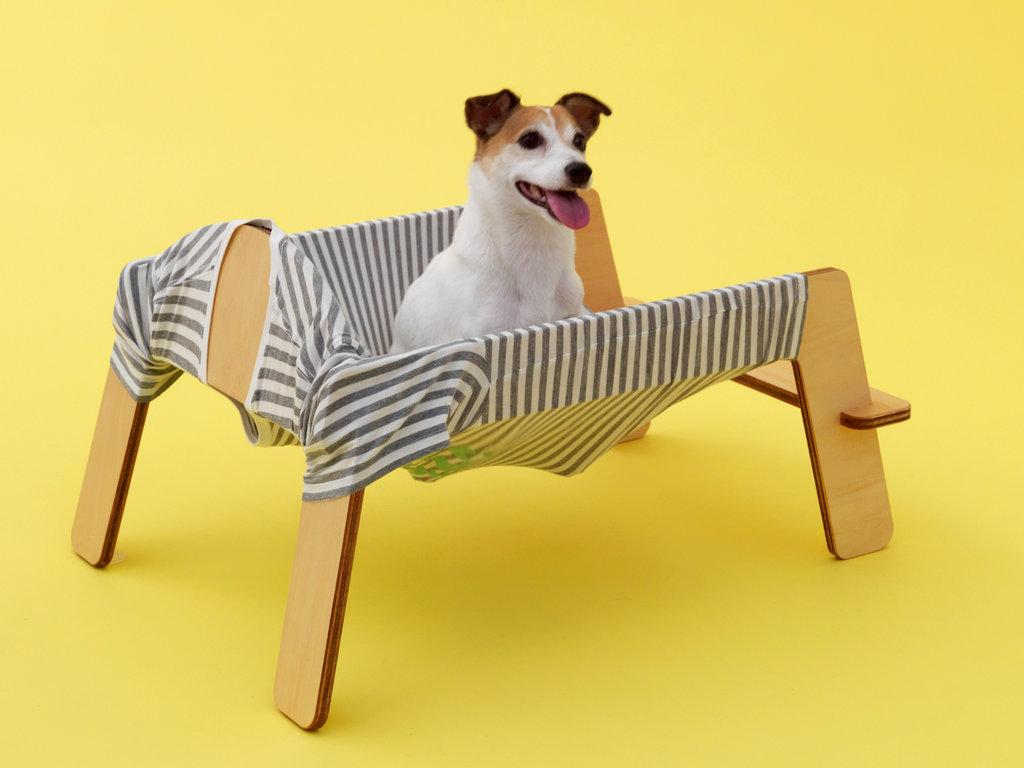What animal is present in the image? There is a dog in the image. What is the dog doing in the image? The dog is sitting on a custom-made chair. Where is the faucet located in the image? There is no faucet present in the image. What type of attempt is the dog making in the image? The image does not depict any attempt by the dog; it is simply sitting on a custom-made chair. 